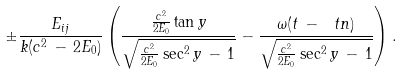Convert formula to latex. <formula><loc_0><loc_0><loc_500><loc_500>\pm \frac { E _ { i j } } { k ( c ^ { 2 } \, - \, 2 E _ { 0 } ) } \left ( \frac { \frac { c ^ { 2 } } { 2 E _ { 0 } } \tan y } { \sqrt { \frac { c ^ { 2 } } { 2 E _ { 0 } } \sec ^ { 2 } y \, - \, 1 } } - \frac { \omega ( t \, - \, \ t n ) } { \sqrt { \frac { c ^ { 2 } } { 2 E _ { 0 } } \sec ^ { 2 } y \, - \, 1 } } \right ) .</formula> 